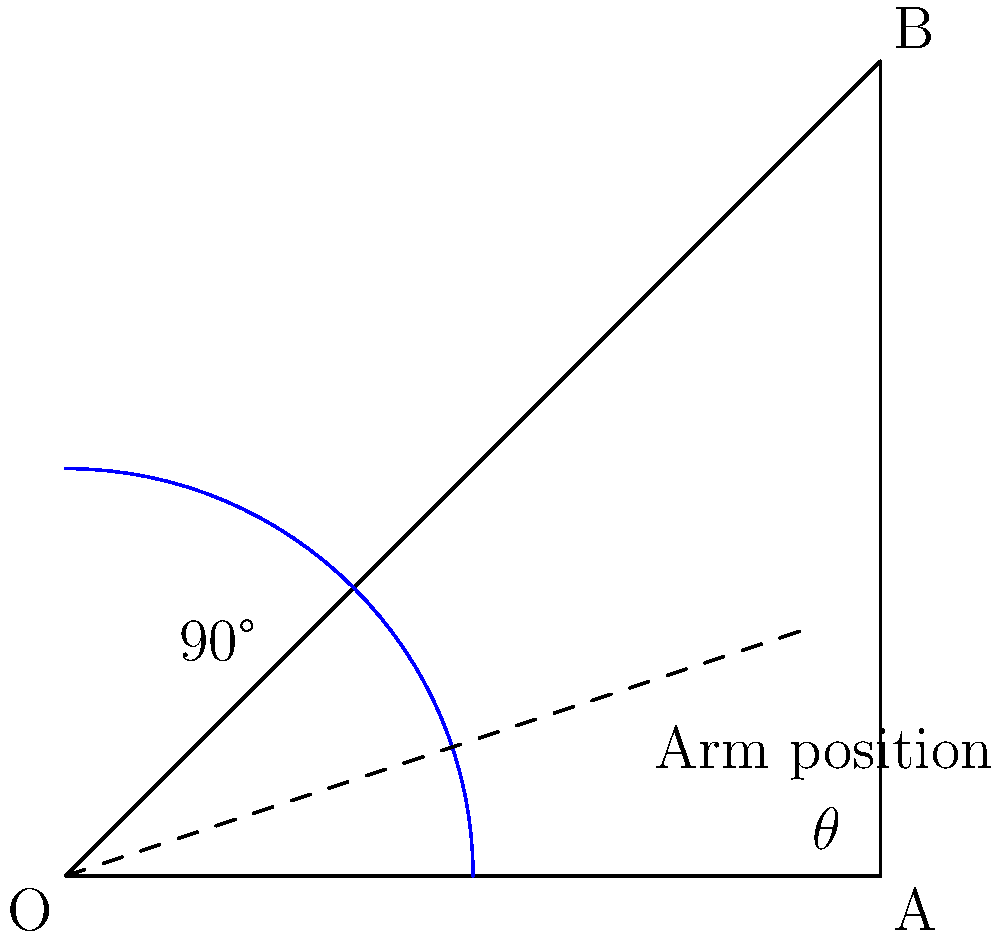During a baseball pitch, a pitcher's arm moves through various angles. In the diagram, angle $\theta$ represents the angle between the pitcher's arm and the horizontal ground at a certain point in the throw. If the pitcher's arm forms a right angle with the ground at the peak of the throw, what is the value of $\theta$? Let's approach this step-by-step:

1) In the diagram, we see a right-angled triangle OAB.

2) The right angle (90°) is at point O, where the vertical and horizontal lines meet.

3) The angle we're looking for, $\theta$, is at point A.

4) In a right-angled triangle, the sum of all angles must be 180°.

5) We can express this as an equation:
   $90° + \theta + \text{unknown angle} = 180°$

6) In a right-angled triangle, the two non-right angles are always complementary, meaning they add up to 90°.

7) Therefore, $\theta + \text{unknown angle} = 90°$

8) Since $\theta$ and the unknown angle must add up to 90°, and we're told that at the peak of the throw, the arm forms a right angle (90°) with the ground, we can conclude that $\theta$ must be the complement of 90°.

9) The complement of an angle is found by subtracting it from 90°:
   $\theta = 90° - 90° = 0°$

Therefore, the value of $\theta$ is 0°.
Answer: 0° 